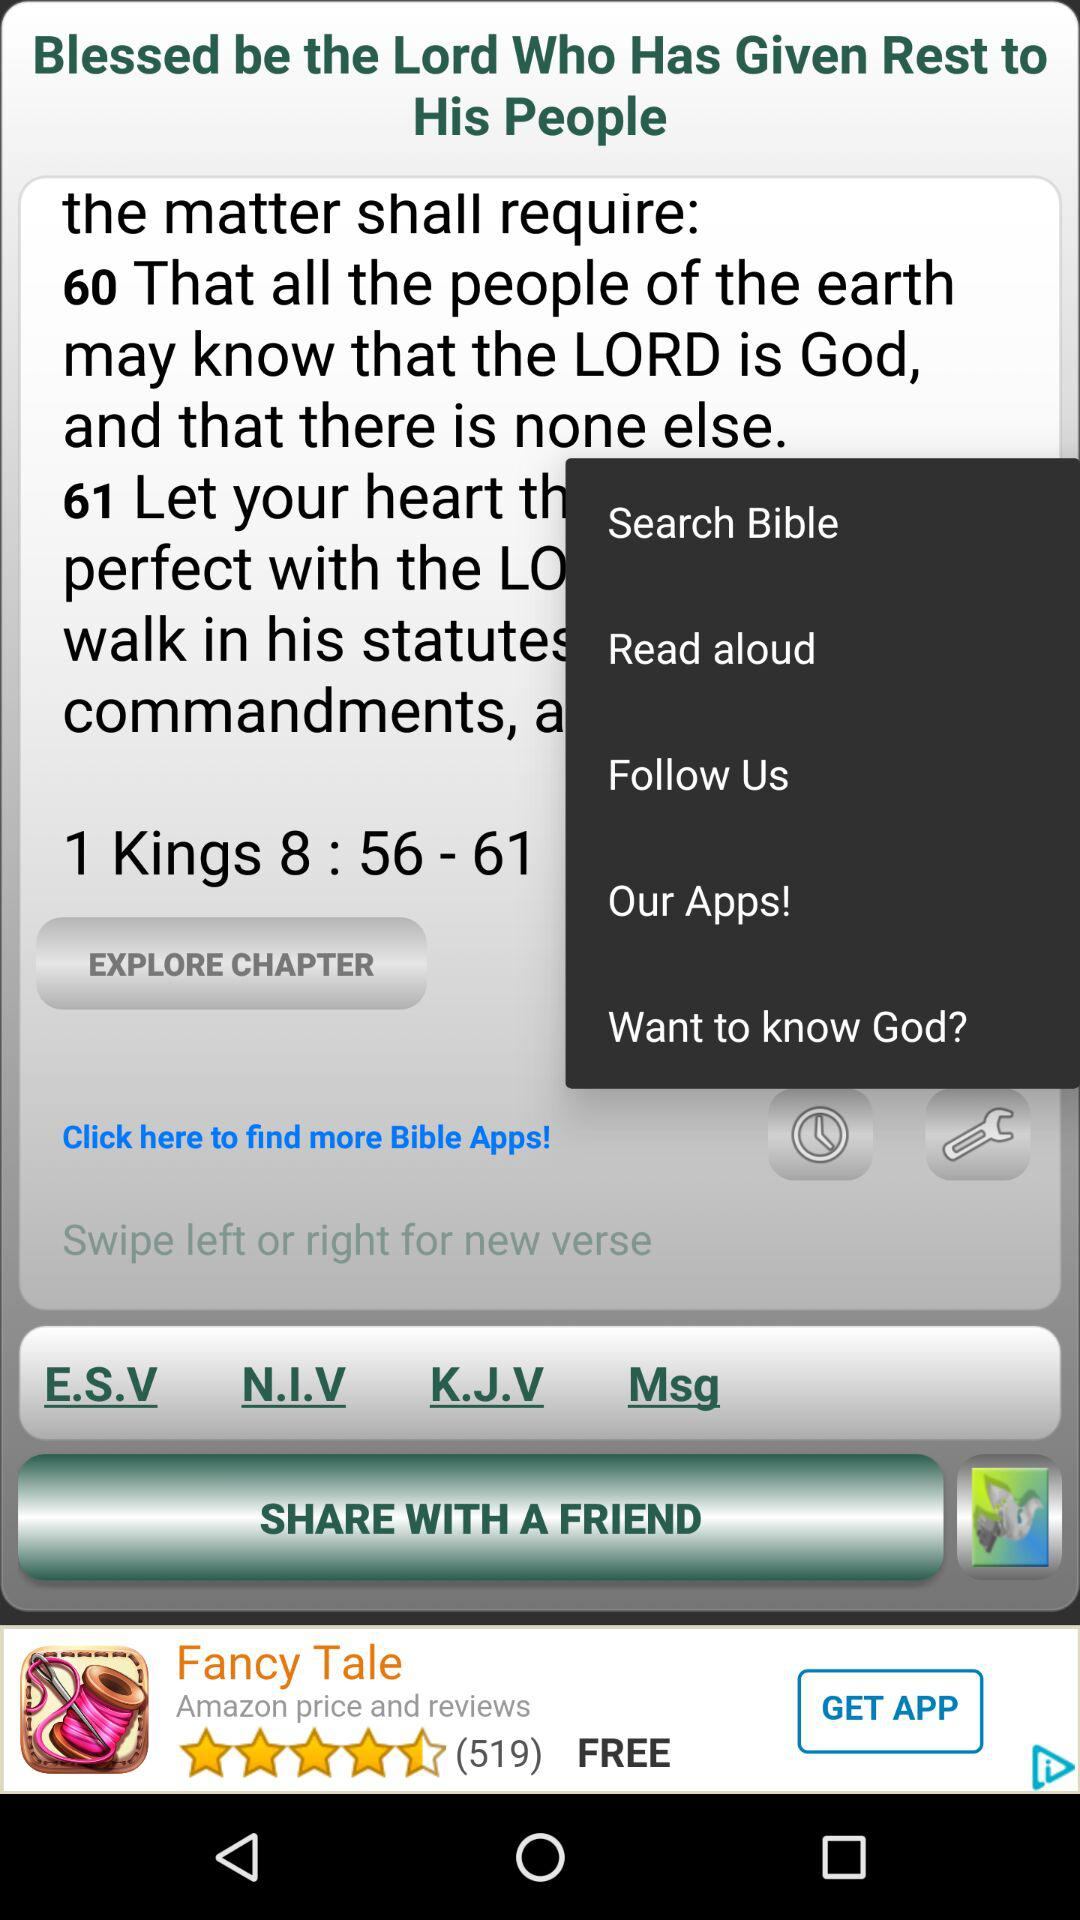What is the chapter number? The chapter number is 8. 